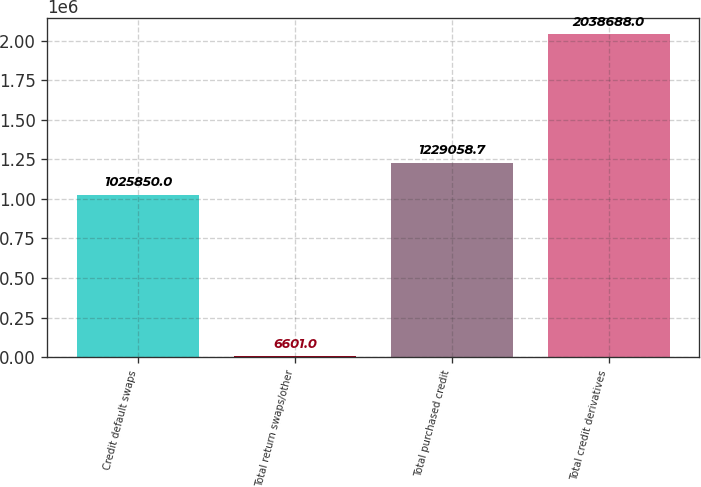Convert chart. <chart><loc_0><loc_0><loc_500><loc_500><bar_chart><fcel>Credit default swaps<fcel>Total return swaps/other<fcel>Total purchased credit<fcel>Total credit derivatives<nl><fcel>1.02585e+06<fcel>6601<fcel>1.22906e+06<fcel>2.03869e+06<nl></chart> 